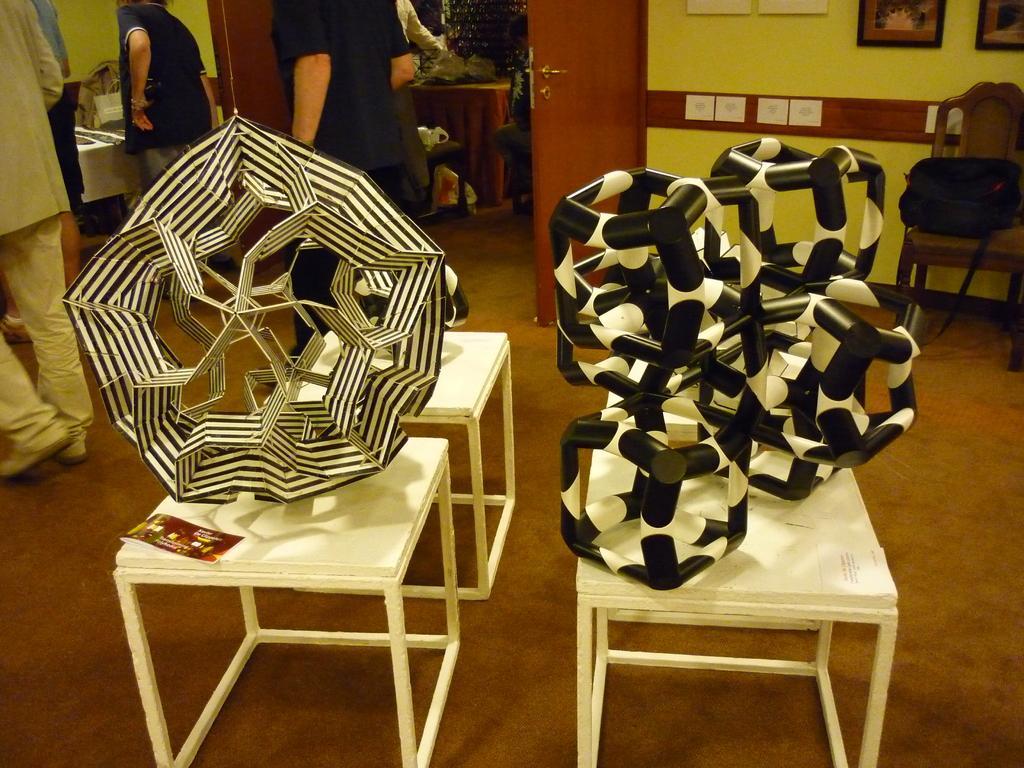Can you describe this image briefly? This image is clicked in a room. In the middle there are three tables on that there are some thing. In the background there are some people, door, wall and photo frame. On the right there is a chair on that there is a bag. 